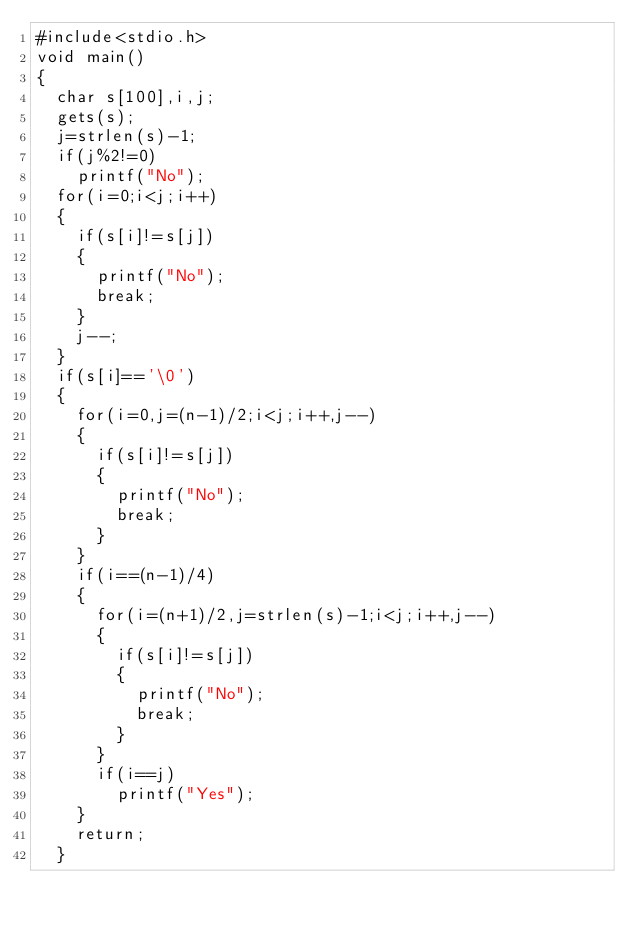Convert code to text. <code><loc_0><loc_0><loc_500><loc_500><_C_>#include<stdio.h>
void main()
{
  char s[100],i,j;
  gets(s);
  j=strlen(s)-1;
  if(j%2!=0)
  	printf("No");  
  for(i=0;i<j;i++)
  {
    if(s[i]!=s[j])
    {
      printf("No");
      break;
    }
    j--;
  }
  if(s[i]=='\0')
  {
    for(i=0,j=(n-1)/2;i<j;i++,j--)
    {
      if(s[i]!=s[j])
      {
        printf("No");
        break;
      }
    }
    if(i==(n-1)/4)
    {
      for(i=(n+1)/2,j=strlen(s)-1;i<j;i++,j--)
      {
        if(s[i]!=s[j])
        {
          printf("No");
          break;
        }
      }
      if(i==j)
        printf("Yes");
    }
    return;
  }
      
      
</code> 